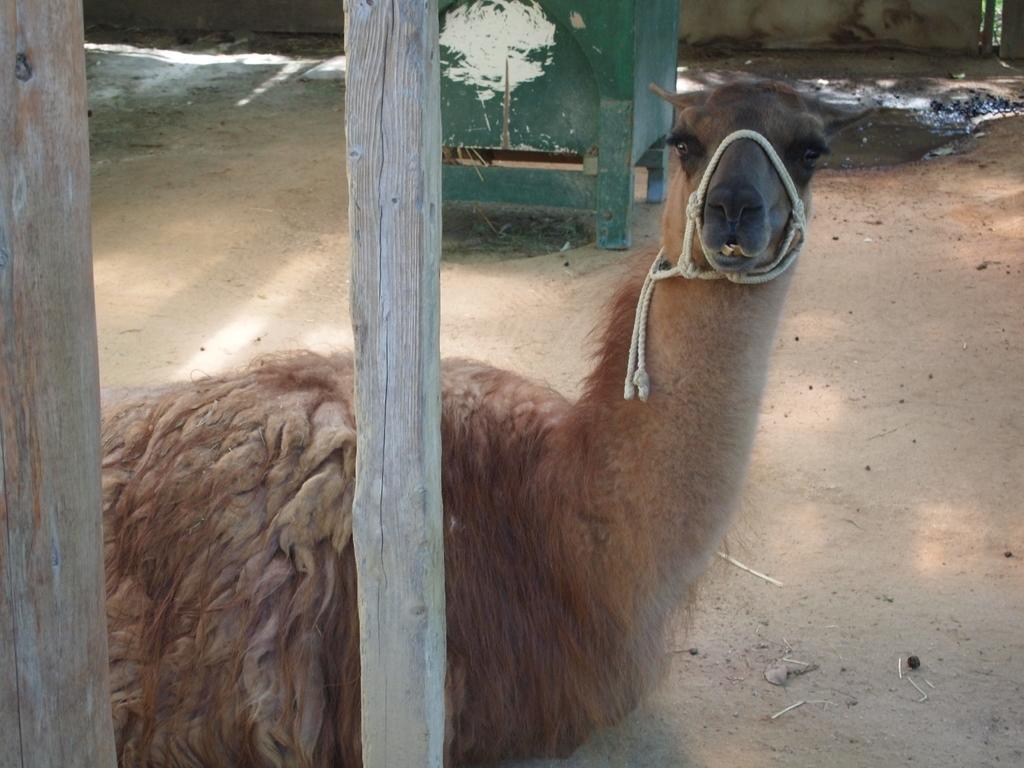What animal is in the image? There is a camel in the image. What is the position of the camel in the image? The camel is sitting on the ground. What objects are in front of the camel? There are two wooden sticks in front of the camel. What can be seen behind the camel? There is an object behind the camel. What type of oatmeal is being served to the women in the image? There are no women or oatmeal present in the image; it features a camel sitting on the ground with two wooden sticks in front of it and an object behind it. 